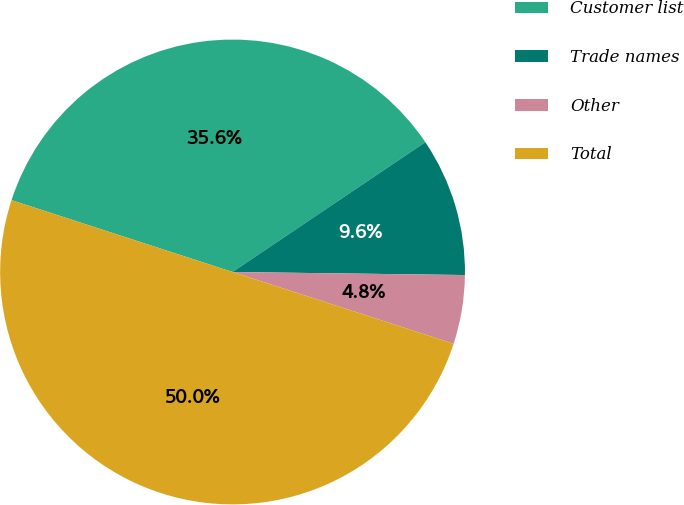<chart> <loc_0><loc_0><loc_500><loc_500><pie_chart><fcel>Customer list<fcel>Trade names<fcel>Other<fcel>Total<nl><fcel>35.57%<fcel>9.64%<fcel>4.79%<fcel>50.0%<nl></chart> 